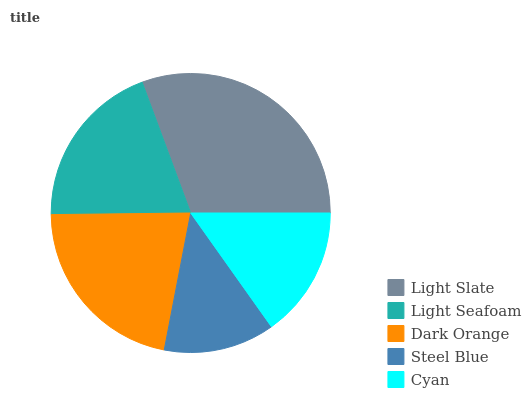Is Steel Blue the minimum?
Answer yes or no. Yes. Is Light Slate the maximum?
Answer yes or no. Yes. Is Light Seafoam the minimum?
Answer yes or no. No. Is Light Seafoam the maximum?
Answer yes or no. No. Is Light Slate greater than Light Seafoam?
Answer yes or no. Yes. Is Light Seafoam less than Light Slate?
Answer yes or no. Yes. Is Light Seafoam greater than Light Slate?
Answer yes or no. No. Is Light Slate less than Light Seafoam?
Answer yes or no. No. Is Light Seafoam the high median?
Answer yes or no. Yes. Is Light Seafoam the low median?
Answer yes or no. Yes. Is Dark Orange the high median?
Answer yes or no. No. Is Light Slate the low median?
Answer yes or no. No. 